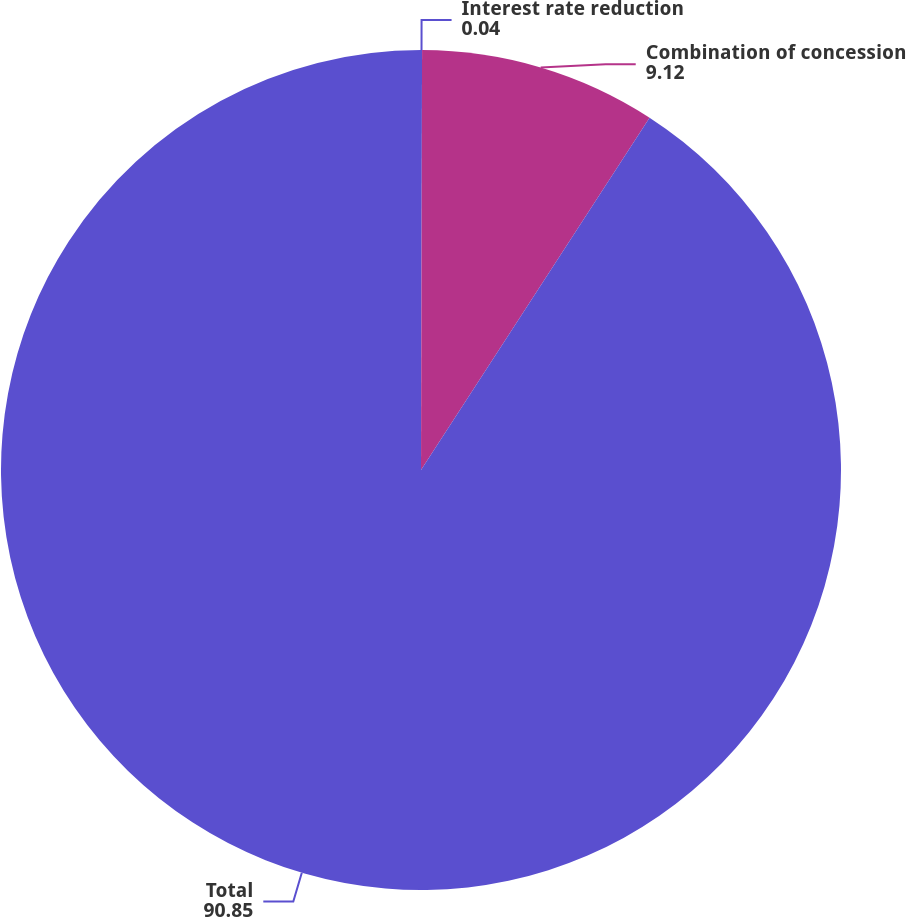<chart> <loc_0><loc_0><loc_500><loc_500><pie_chart><fcel>Interest rate reduction<fcel>Combination of concession<fcel>Total<nl><fcel>0.04%<fcel>9.12%<fcel>90.85%<nl></chart> 